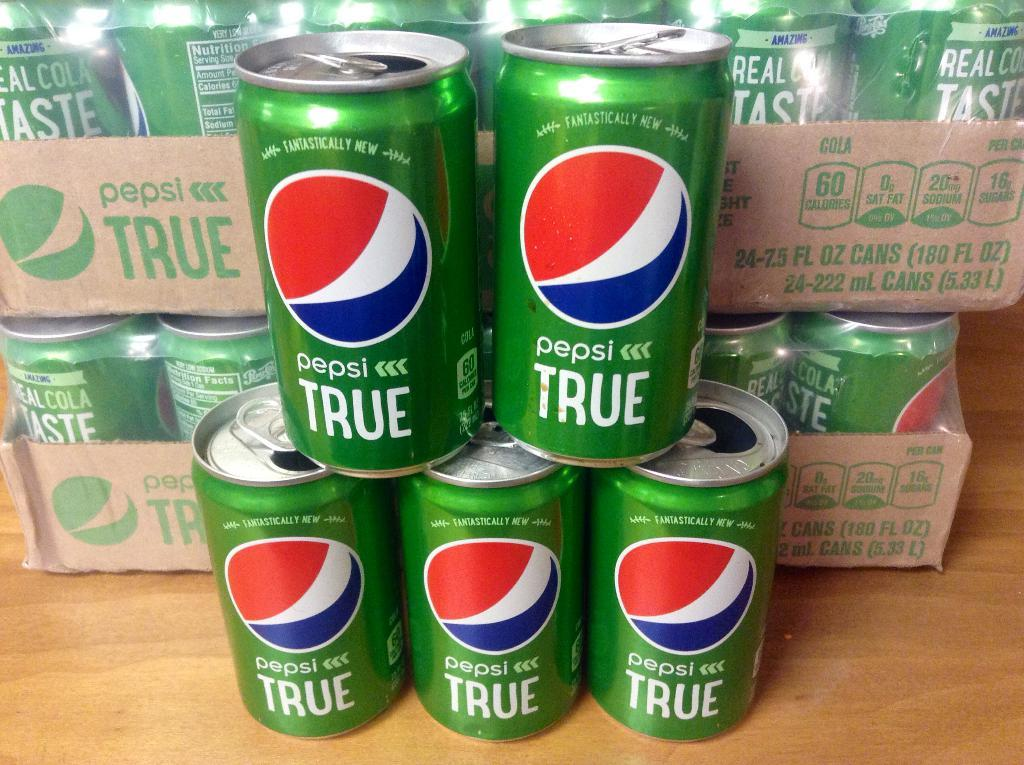<image>
Relay a brief, clear account of the picture shown. some pepsi cans with the word true on them 